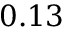Convert formula to latex. <formula><loc_0><loc_0><loc_500><loc_500>0 . 1 3</formula> 